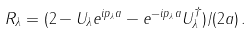<formula> <loc_0><loc_0><loc_500><loc_500>R _ { \lambda } = ( 2 - U _ { \lambda } e ^ { i p _ { \lambda } a } - e ^ { - i p _ { \lambda } a } U _ { \lambda } ^ { \dagger } ) / ( 2 a ) \, .</formula> 